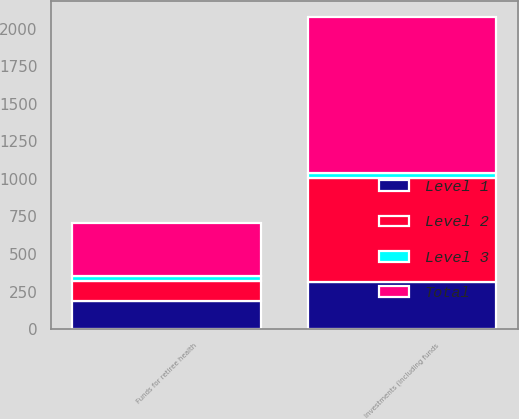<chart> <loc_0><loc_0><loc_500><loc_500><stacked_bar_chart><ecel><fcel>Funds for retiree health<fcel>Investments (including funds<nl><fcel>Level 1<fcel>185<fcel>312<nl><fcel>Level 2<fcel>137<fcel>697<nl><fcel>Level 3<fcel>31<fcel>31<nl><fcel>Total<fcel>353<fcel>1040<nl></chart> 